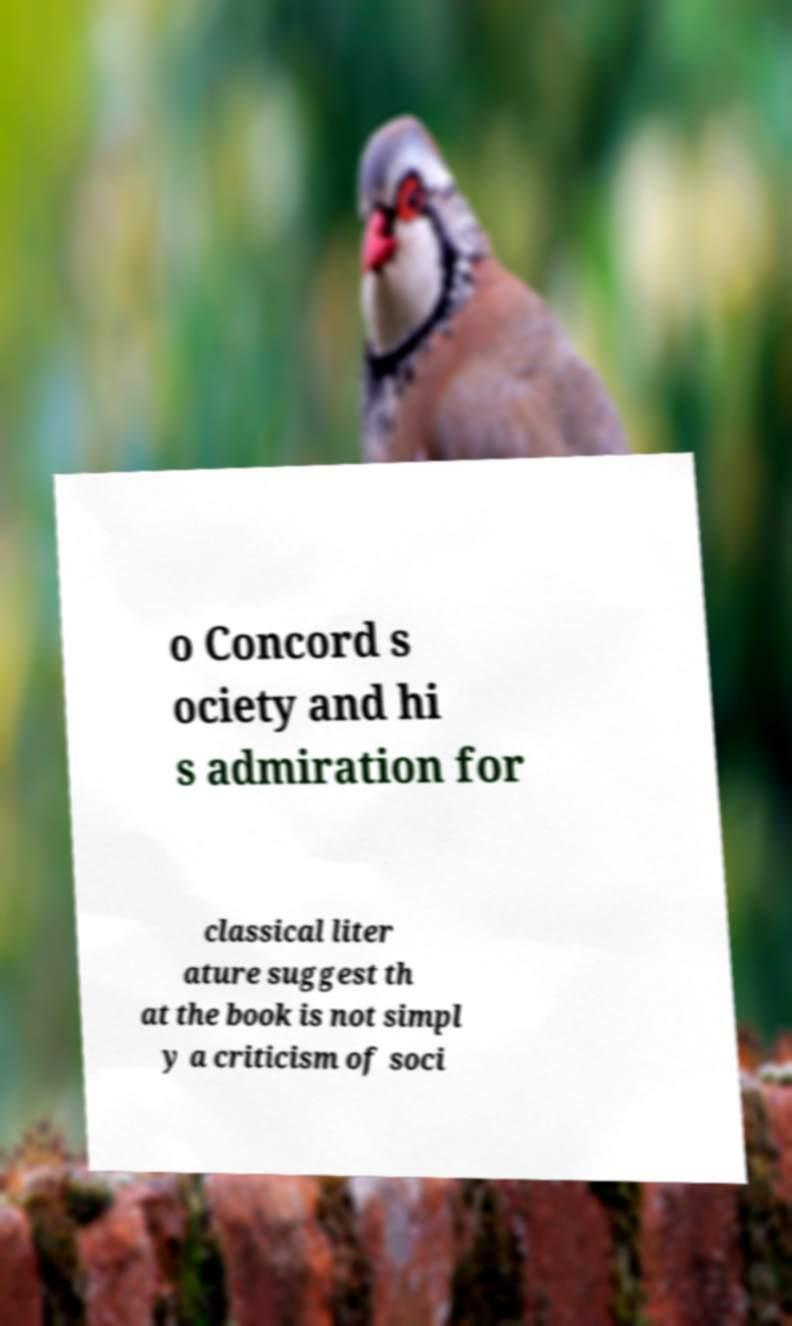I need the written content from this picture converted into text. Can you do that? o Concord s ociety and hi s admiration for classical liter ature suggest th at the book is not simpl y a criticism of soci 